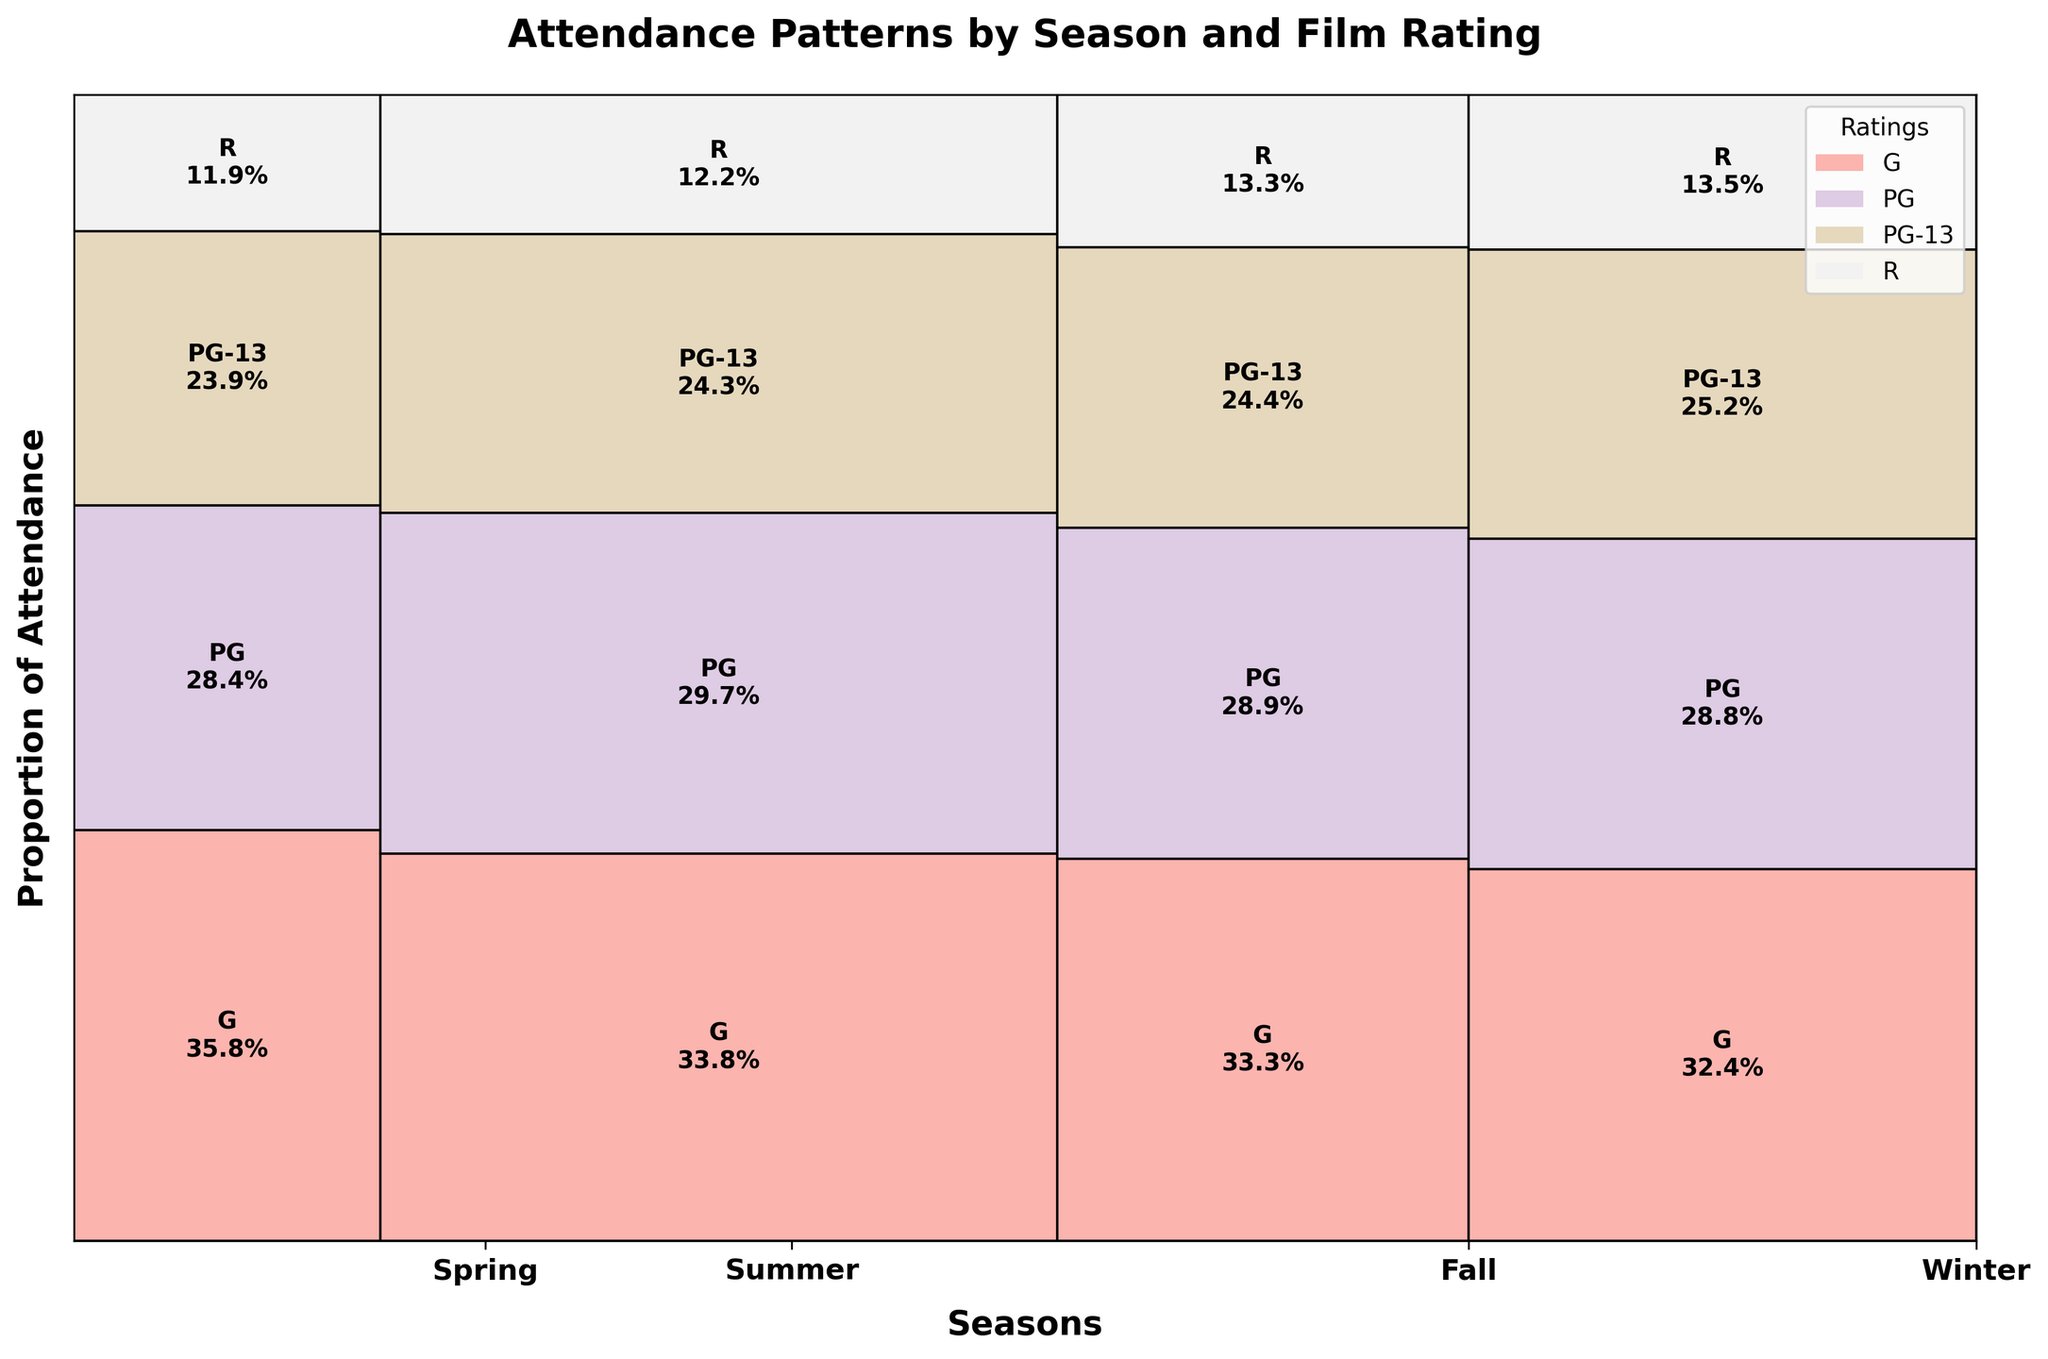What's the title of the plot? The title is usually positioned at the top of the plot, centered and in bold text. It directly states what the plot is about.
Answer: Attendance Patterns by Season and Film Rating How many seasons are displayed in the plot? Count the number of unique season labels along the x-axis of the plot. Each label represents a season.
Answer: 4 Which season has the highest proportion of 'G' rated attendance? By observing the vertical height of the 'G' rated sections in each seasonal bar, locate the season with the tallest 'G' portion.
Answer: Summer What is the proportion of 'PG-13' rated attendance in Winter? Look at the height of the 'PG-13' rectangle in the Winter section, and calculate its proportion compared to the total Winter bar.
Answer: 35% Which season has the smallest overall attendance? Compare the widths of the boxes representing each season; the narrower the box, the smaller the attendance.
Answer: Spring Is 'R' rated attendance more popular in Fall or Winter? Compare the heights of the 'R' rated sections for Fall and Winter. The taller rectangle indicates higher attendance.
Answer: Winter What is the combined proportion of 'G' and 'PG' rated attendance in Summer? Sum the heights of the 'G' and 'PG' sections in the Summer bar to get the combined proportion.
Answer: 70% How does the 'PG' rated attendance in Fall compare to Spring? Compare the heights of the 'PG' sections in the Fall and Spring bars. The taller section indicates higher attendance.
Answer: Fall Which rating has the least attendance in Spring? Identify the smallest rectangle in the Spring section of the plot, which indicates the least attendance.
Answer: R What season shows the most evenly distributed attendance across all ratings? Find the season where the sections have the most similar heights, indicating a balanced attendance distribution across all ratings.
Answer: Winter 